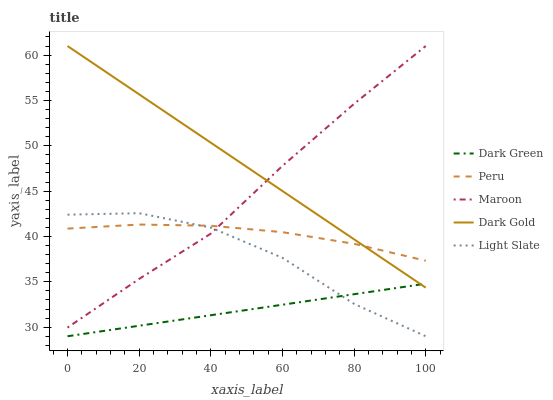Does Maroon have the minimum area under the curve?
Answer yes or no. No. Does Maroon have the maximum area under the curve?
Answer yes or no. No. Is Dark Gold the smoothest?
Answer yes or no. No. Is Dark Gold the roughest?
Answer yes or no. No. Does Dark Gold have the lowest value?
Answer yes or no. No. Does Peru have the highest value?
Answer yes or no. No. Is Light Slate less than Dark Gold?
Answer yes or no. Yes. Is Dark Gold greater than Light Slate?
Answer yes or no. Yes. Does Light Slate intersect Dark Gold?
Answer yes or no. No. 